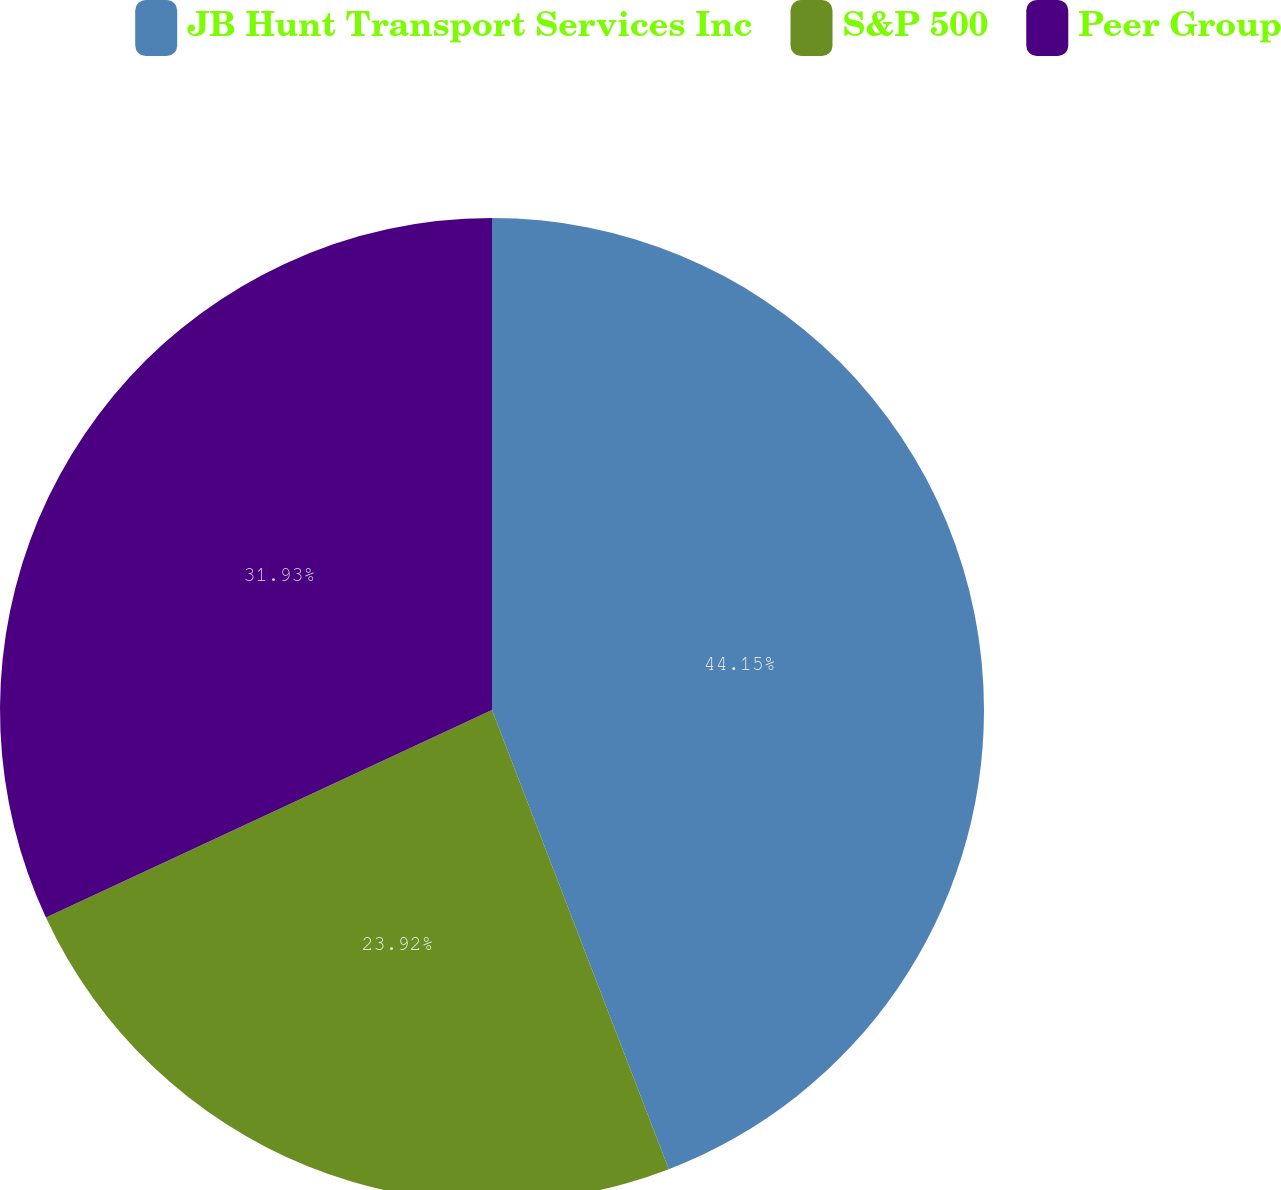Convert chart. <chart><loc_0><loc_0><loc_500><loc_500><pie_chart><fcel>JB Hunt Transport Services Inc<fcel>S&P 500<fcel>Peer Group<nl><fcel>44.15%<fcel>23.92%<fcel>31.93%<nl></chart> 